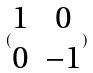Convert formula to latex. <formula><loc_0><loc_0><loc_500><loc_500>( \begin{matrix} 1 & 0 \\ 0 & - 1 \end{matrix} )</formula> 